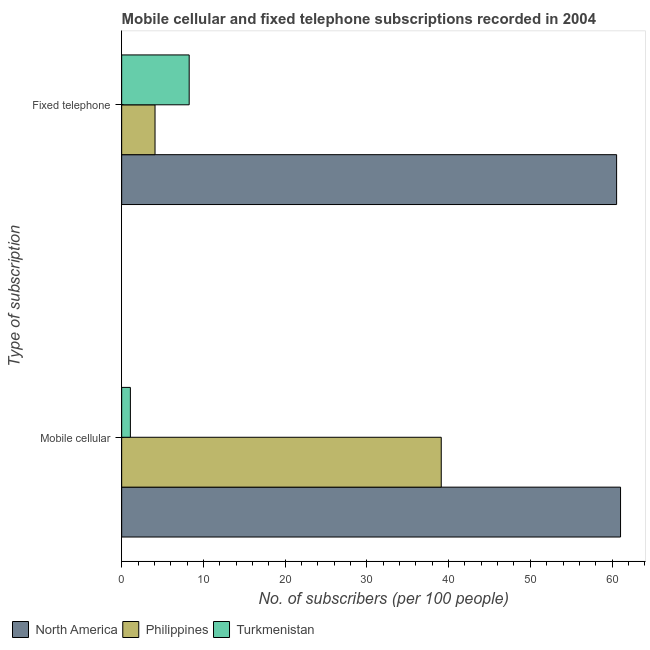How many different coloured bars are there?
Offer a very short reply. 3. How many groups of bars are there?
Give a very brief answer. 2. Are the number of bars on each tick of the Y-axis equal?
Give a very brief answer. Yes. How many bars are there on the 1st tick from the bottom?
Ensure brevity in your answer.  3. What is the label of the 2nd group of bars from the top?
Your response must be concise. Mobile cellular. What is the number of fixed telephone subscribers in Philippines?
Provide a short and direct response. 4.08. Across all countries, what is the maximum number of fixed telephone subscribers?
Give a very brief answer. 60.56. Across all countries, what is the minimum number of fixed telephone subscribers?
Ensure brevity in your answer.  4.08. In which country was the number of fixed telephone subscribers maximum?
Make the answer very short. North America. In which country was the number of mobile cellular subscribers minimum?
Your answer should be compact. Turkmenistan. What is the total number of fixed telephone subscribers in the graph?
Your answer should be compact. 72.9. What is the difference between the number of mobile cellular subscribers in Philippines and that in North America?
Ensure brevity in your answer.  -21.94. What is the difference between the number of fixed telephone subscribers in North America and the number of mobile cellular subscribers in Philippines?
Provide a succinct answer. 21.46. What is the average number of fixed telephone subscribers per country?
Offer a terse response. 24.3. What is the difference between the number of fixed telephone subscribers and number of mobile cellular subscribers in Philippines?
Ensure brevity in your answer.  -35.02. In how many countries, is the number of mobile cellular subscribers greater than 50 ?
Offer a terse response. 1. What is the ratio of the number of fixed telephone subscribers in Turkmenistan to that in Philippines?
Provide a succinct answer. 2.02. Is the number of mobile cellular subscribers in Philippines less than that in North America?
Your response must be concise. Yes. In how many countries, is the number of mobile cellular subscribers greater than the average number of mobile cellular subscribers taken over all countries?
Ensure brevity in your answer.  2. What does the 1st bar from the bottom in Mobile cellular represents?
Provide a succinct answer. North America. Are all the bars in the graph horizontal?
Provide a short and direct response. Yes. How many countries are there in the graph?
Offer a very short reply. 3. What is the difference between two consecutive major ticks on the X-axis?
Give a very brief answer. 10. Where does the legend appear in the graph?
Offer a very short reply. Bottom left. How many legend labels are there?
Offer a terse response. 3. What is the title of the graph?
Give a very brief answer. Mobile cellular and fixed telephone subscriptions recorded in 2004. What is the label or title of the X-axis?
Your answer should be very brief. No. of subscribers (per 100 people). What is the label or title of the Y-axis?
Offer a terse response. Type of subscription. What is the No. of subscribers (per 100 people) of North America in Mobile cellular?
Provide a succinct answer. 61.04. What is the No. of subscribers (per 100 people) in Philippines in Mobile cellular?
Your response must be concise. 39.1. What is the No. of subscribers (per 100 people) in Turkmenistan in Mobile cellular?
Offer a terse response. 1.07. What is the No. of subscribers (per 100 people) in North America in Fixed telephone?
Provide a short and direct response. 60.56. What is the No. of subscribers (per 100 people) of Philippines in Fixed telephone?
Provide a succinct answer. 4.08. What is the No. of subscribers (per 100 people) in Turkmenistan in Fixed telephone?
Give a very brief answer. 8.26. Across all Type of subscription, what is the maximum No. of subscribers (per 100 people) of North America?
Your answer should be very brief. 61.04. Across all Type of subscription, what is the maximum No. of subscribers (per 100 people) of Philippines?
Your answer should be very brief. 39.1. Across all Type of subscription, what is the maximum No. of subscribers (per 100 people) of Turkmenistan?
Ensure brevity in your answer.  8.26. Across all Type of subscription, what is the minimum No. of subscribers (per 100 people) of North America?
Offer a very short reply. 60.56. Across all Type of subscription, what is the minimum No. of subscribers (per 100 people) of Philippines?
Keep it short and to the point. 4.08. Across all Type of subscription, what is the minimum No. of subscribers (per 100 people) of Turkmenistan?
Your response must be concise. 1.07. What is the total No. of subscribers (per 100 people) of North America in the graph?
Provide a short and direct response. 121.6. What is the total No. of subscribers (per 100 people) of Philippines in the graph?
Ensure brevity in your answer.  43.18. What is the total No. of subscribers (per 100 people) of Turkmenistan in the graph?
Your response must be concise. 9.33. What is the difference between the No. of subscribers (per 100 people) of North America in Mobile cellular and that in Fixed telephone?
Make the answer very short. 0.48. What is the difference between the No. of subscribers (per 100 people) of Philippines in Mobile cellular and that in Fixed telephone?
Offer a very short reply. 35.02. What is the difference between the No. of subscribers (per 100 people) in Turkmenistan in Mobile cellular and that in Fixed telephone?
Keep it short and to the point. -7.19. What is the difference between the No. of subscribers (per 100 people) of North America in Mobile cellular and the No. of subscribers (per 100 people) of Philippines in Fixed telephone?
Your answer should be very brief. 56.96. What is the difference between the No. of subscribers (per 100 people) of North America in Mobile cellular and the No. of subscribers (per 100 people) of Turkmenistan in Fixed telephone?
Ensure brevity in your answer.  52.78. What is the difference between the No. of subscribers (per 100 people) in Philippines in Mobile cellular and the No. of subscribers (per 100 people) in Turkmenistan in Fixed telephone?
Offer a terse response. 30.84. What is the average No. of subscribers (per 100 people) in North America per Type of subscription?
Provide a short and direct response. 60.8. What is the average No. of subscribers (per 100 people) in Philippines per Type of subscription?
Offer a terse response. 21.59. What is the average No. of subscribers (per 100 people) of Turkmenistan per Type of subscription?
Provide a short and direct response. 4.66. What is the difference between the No. of subscribers (per 100 people) in North America and No. of subscribers (per 100 people) in Philippines in Mobile cellular?
Provide a short and direct response. 21.94. What is the difference between the No. of subscribers (per 100 people) of North America and No. of subscribers (per 100 people) of Turkmenistan in Mobile cellular?
Ensure brevity in your answer.  59.97. What is the difference between the No. of subscribers (per 100 people) in Philippines and No. of subscribers (per 100 people) in Turkmenistan in Mobile cellular?
Your answer should be compact. 38.03. What is the difference between the No. of subscribers (per 100 people) in North America and No. of subscribers (per 100 people) in Philippines in Fixed telephone?
Your answer should be compact. 56.48. What is the difference between the No. of subscribers (per 100 people) in North America and No. of subscribers (per 100 people) in Turkmenistan in Fixed telephone?
Give a very brief answer. 52.3. What is the difference between the No. of subscribers (per 100 people) in Philippines and No. of subscribers (per 100 people) in Turkmenistan in Fixed telephone?
Your answer should be compact. -4.18. What is the ratio of the No. of subscribers (per 100 people) of Philippines in Mobile cellular to that in Fixed telephone?
Your response must be concise. 9.58. What is the ratio of the No. of subscribers (per 100 people) of Turkmenistan in Mobile cellular to that in Fixed telephone?
Make the answer very short. 0.13. What is the difference between the highest and the second highest No. of subscribers (per 100 people) of North America?
Keep it short and to the point. 0.48. What is the difference between the highest and the second highest No. of subscribers (per 100 people) in Philippines?
Your response must be concise. 35.02. What is the difference between the highest and the second highest No. of subscribers (per 100 people) of Turkmenistan?
Your response must be concise. 7.19. What is the difference between the highest and the lowest No. of subscribers (per 100 people) in North America?
Provide a short and direct response. 0.48. What is the difference between the highest and the lowest No. of subscribers (per 100 people) in Philippines?
Ensure brevity in your answer.  35.02. What is the difference between the highest and the lowest No. of subscribers (per 100 people) of Turkmenistan?
Provide a short and direct response. 7.19. 